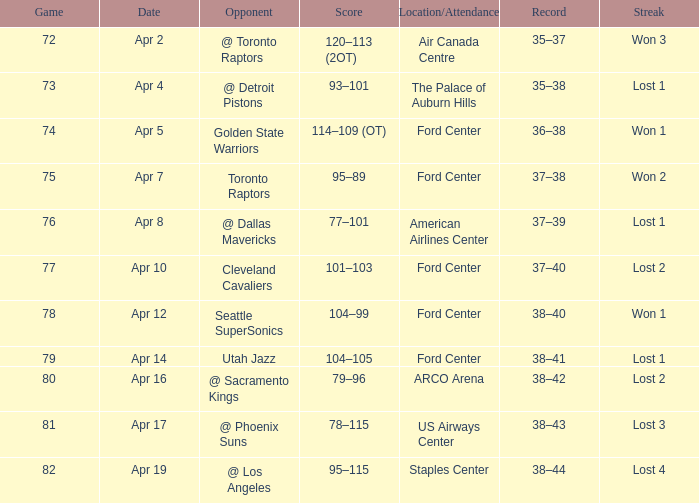What was the record for less than 78 games and a score of 114–109 (ot)? 36–38. 